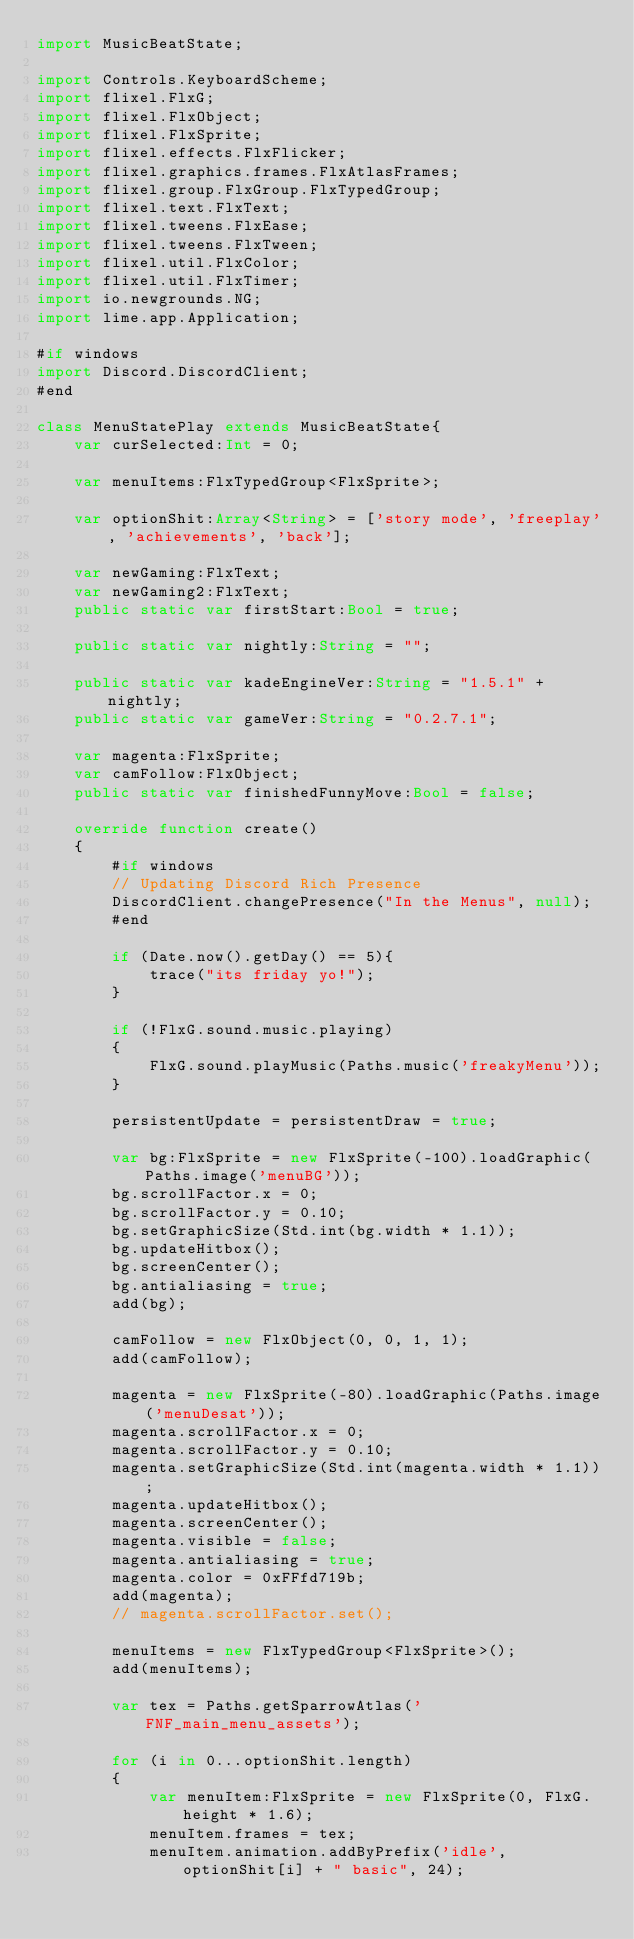<code> <loc_0><loc_0><loc_500><loc_500><_Haxe_>import MusicBeatState;

import Controls.KeyboardScheme;
import flixel.FlxG;
import flixel.FlxObject;
import flixel.FlxSprite;
import flixel.effects.FlxFlicker;
import flixel.graphics.frames.FlxAtlasFrames;
import flixel.group.FlxGroup.FlxTypedGroup;
import flixel.text.FlxText;
import flixel.tweens.FlxEase;
import flixel.tweens.FlxTween;
import flixel.util.FlxColor;
import flixel.util.FlxTimer;
import io.newgrounds.NG;
import lime.app.Application;

#if windows
import Discord.DiscordClient;
#end

class MenuStatePlay extends MusicBeatState{
    var curSelected:Int = 0;

	var menuItems:FlxTypedGroup<FlxSprite>;

	var optionShit:Array<String> = ['story mode', 'freeplay', 'achievements', 'back'];

	var newGaming:FlxText;
	var newGaming2:FlxText;
	public static var firstStart:Bool = true;

	public static var nightly:String = "";

	public static var kadeEngineVer:String = "1.5.1" + nightly;
	public static var gameVer:String = "0.2.7.1";

	var magenta:FlxSprite;
	var camFollow:FlxObject;
	public static var finishedFunnyMove:Bool = false;

	override function create()
	{
		#if windows
		// Updating Discord Rich Presence
		DiscordClient.changePresence("In the Menus", null);
		#end

		if (Date.now().getDay() == 5){
			trace("its friday yo!");
		}

		if (!FlxG.sound.music.playing)
		{
			FlxG.sound.playMusic(Paths.music('freakyMenu'));
		}

		persistentUpdate = persistentDraw = true;

		var bg:FlxSprite = new FlxSprite(-100).loadGraphic(Paths.image('menuBG'));
		bg.scrollFactor.x = 0;
		bg.scrollFactor.y = 0.10;
		bg.setGraphicSize(Std.int(bg.width * 1.1));
		bg.updateHitbox();
		bg.screenCenter();
		bg.antialiasing = true;
		add(bg);

		camFollow = new FlxObject(0, 0, 1, 1);
		add(camFollow);

		magenta = new FlxSprite(-80).loadGraphic(Paths.image('menuDesat'));
		magenta.scrollFactor.x = 0;
		magenta.scrollFactor.y = 0.10;
		magenta.setGraphicSize(Std.int(magenta.width * 1.1));
		magenta.updateHitbox();
		magenta.screenCenter();
		magenta.visible = false;
		magenta.antialiasing = true;
		magenta.color = 0xFFfd719b;
		add(magenta);
		// magenta.scrollFactor.set();

		menuItems = new FlxTypedGroup<FlxSprite>();
		add(menuItems);

		var tex = Paths.getSparrowAtlas('FNF_main_menu_assets');

		for (i in 0...optionShit.length)
		{
			var menuItem:FlxSprite = new FlxSprite(0, FlxG.height * 1.6);
			menuItem.frames = tex;
			menuItem.animation.addByPrefix('idle', optionShit[i] + " basic", 24);</code> 